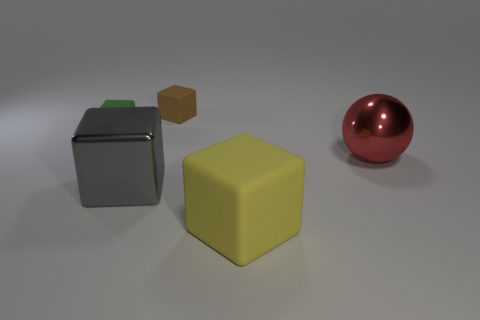Add 5 large blue shiny cubes. How many objects exist? 10 Subtract all spheres. How many objects are left? 4 Subtract 1 green cubes. How many objects are left? 4 Subtract all small rubber cubes. Subtract all big rubber things. How many objects are left? 2 Add 3 small green cubes. How many small green cubes are left? 4 Add 2 large rubber cubes. How many large rubber cubes exist? 3 